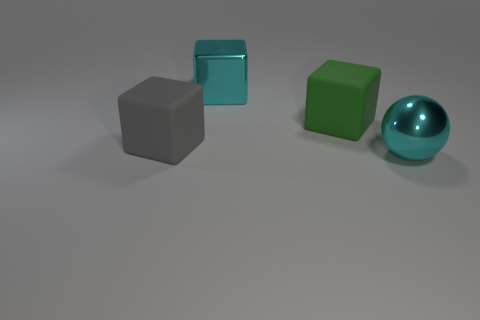Add 2 large cyan balls. How many objects exist? 6 Subtract all cubes. How many objects are left? 1 Subtract all blue matte cylinders. Subtract all rubber cubes. How many objects are left? 2 Add 1 big cyan balls. How many big cyan balls are left? 2 Add 1 large rubber things. How many large rubber things exist? 3 Subtract 0 blue cylinders. How many objects are left? 4 